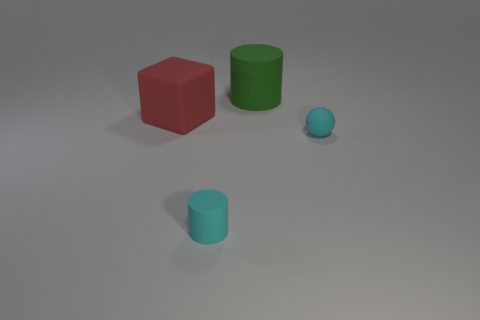Does the tiny thing that is on the left side of the sphere have the same shape as the big red matte thing?
Your answer should be compact. No. Is the number of tiny cyan matte balls less than the number of tiny green matte cylinders?
Keep it short and to the point. No. What number of small rubber cylinders have the same color as the tiny ball?
Ensure brevity in your answer.  1. What material is the object that is the same color as the ball?
Offer a terse response. Rubber. There is a rubber ball; is it the same color as the cylinder that is in front of the large green object?
Provide a short and direct response. Yes. Is the number of purple matte blocks greater than the number of tiny objects?
Ensure brevity in your answer.  No. What size is the other thing that is the same shape as the green rubber object?
Provide a succinct answer. Small. Is the tiny sphere made of the same material as the thing on the left side of the small cyan matte cylinder?
Keep it short and to the point. Yes. What number of objects are rubber objects or big yellow rubber cylinders?
Make the answer very short. 4. Does the cylinder in front of the tiny sphere have the same size as the cyan rubber thing that is behind the cyan cylinder?
Give a very brief answer. Yes. 